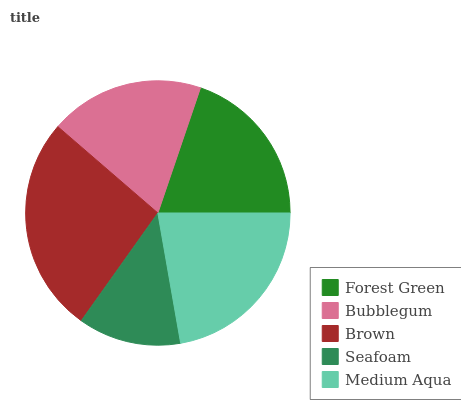Is Seafoam the minimum?
Answer yes or no. Yes. Is Brown the maximum?
Answer yes or no. Yes. Is Bubblegum the minimum?
Answer yes or no. No. Is Bubblegum the maximum?
Answer yes or no. No. Is Forest Green greater than Bubblegum?
Answer yes or no. Yes. Is Bubblegum less than Forest Green?
Answer yes or no. Yes. Is Bubblegum greater than Forest Green?
Answer yes or no. No. Is Forest Green less than Bubblegum?
Answer yes or no. No. Is Forest Green the high median?
Answer yes or no. Yes. Is Forest Green the low median?
Answer yes or no. Yes. Is Medium Aqua the high median?
Answer yes or no. No. Is Medium Aqua the low median?
Answer yes or no. No. 